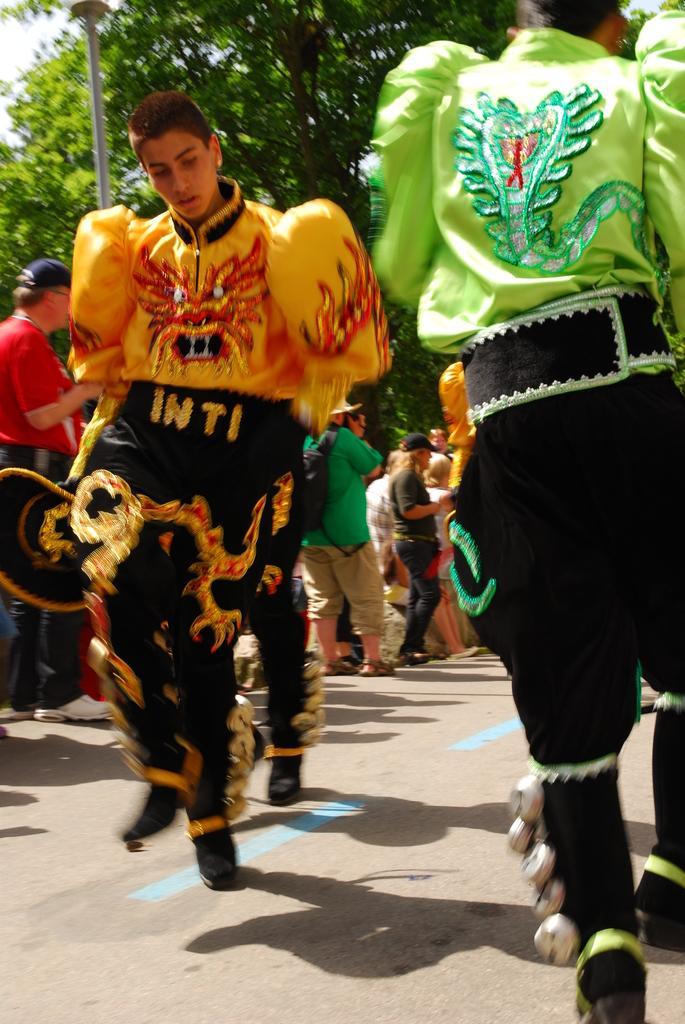Could you give a brief overview of what you see in this image? In the picture I can see these people wearing different costumes are walking on the road and in the background, I can see a few more people standing on the road and I can see a pole and trees. 